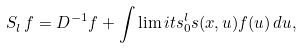<formula> <loc_0><loc_0><loc_500><loc_500>S _ { l } ^ { \, } \, f = D ^ { - 1 } f + \int \lim i t s ^ { l } _ { 0 } s ( x , u ) f ( u ) \, d u ,</formula> 